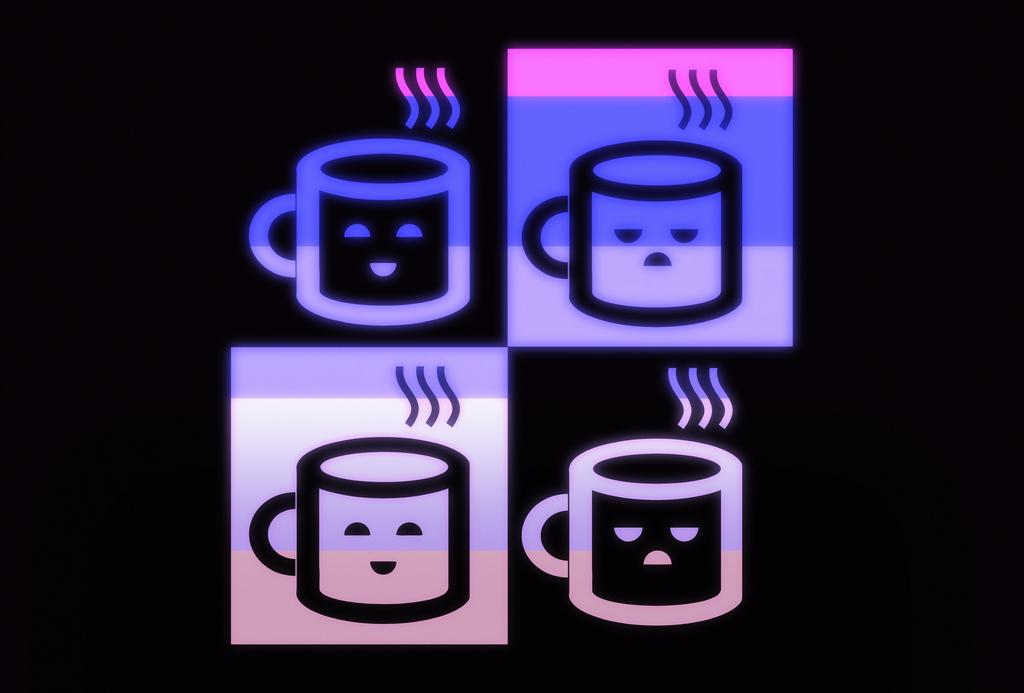What type of editing has been done to the image? The specific type of editing is not mentioned, but we know that the image has been edited. What can be seen in the edited image? There are pictures of cartoon beverage mugs in the image. What type of linen is draped over the cartoon beverage mugs in the image? There is no linen draped over the cartoon beverage mugs in the image, as the facts only mention pictures of cartoon beverage mugs. How many kittens are sitting on the cartoon beverage mugs in the image? There are no kittens present in the image, as the facts only mention pictures of cartoon beverage mugs. 